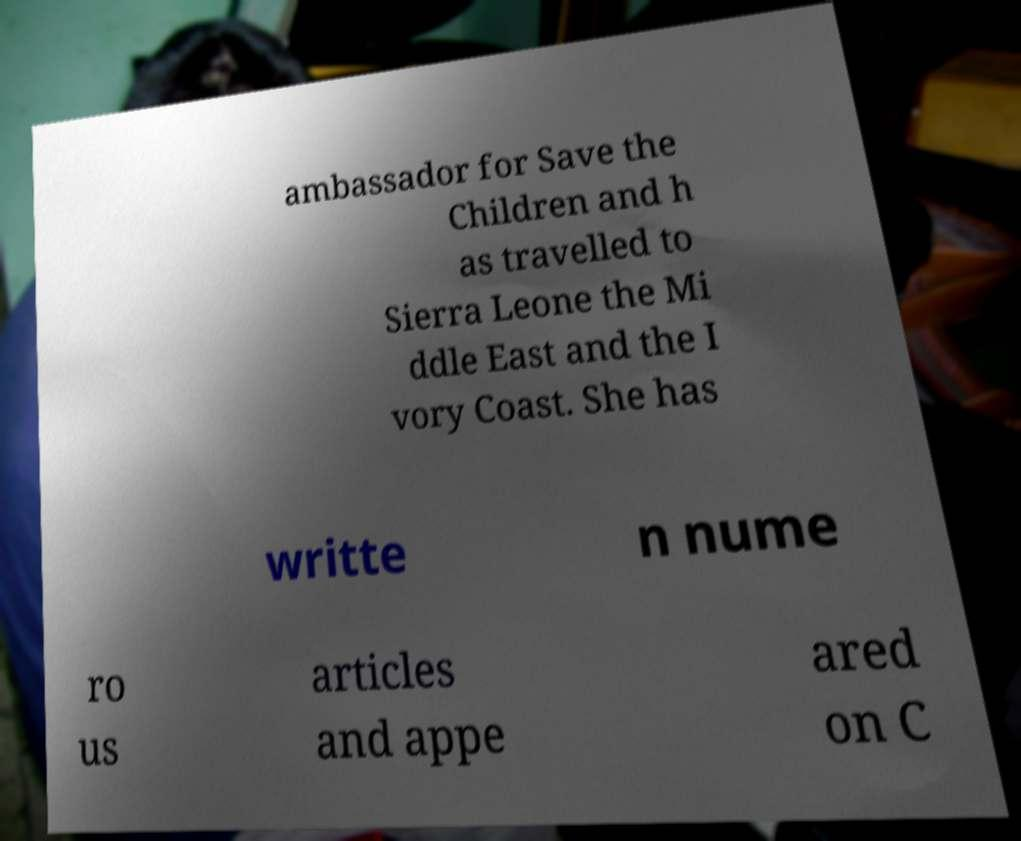Please read and relay the text visible in this image. What does it say? ambassador for Save the Children and h as travelled to Sierra Leone the Mi ddle East and the I vory Coast. She has writte n nume ro us articles and appe ared on C 